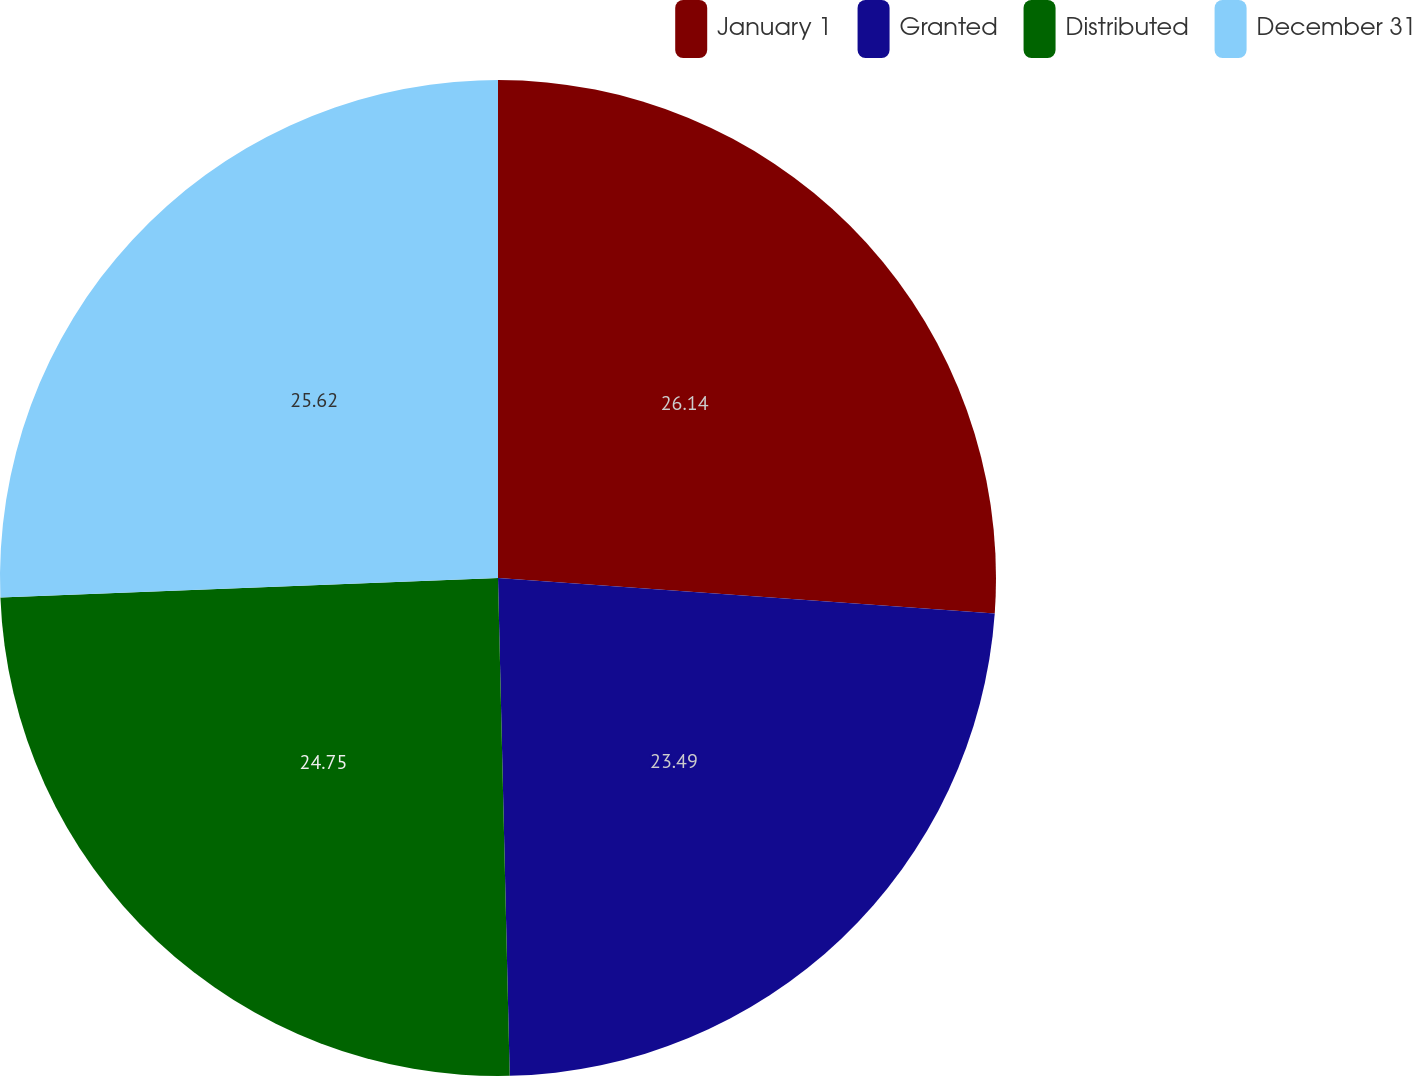Convert chart to OTSL. <chart><loc_0><loc_0><loc_500><loc_500><pie_chart><fcel>January 1<fcel>Granted<fcel>Distributed<fcel>December 31<nl><fcel>26.13%<fcel>23.49%<fcel>24.75%<fcel>25.62%<nl></chart> 